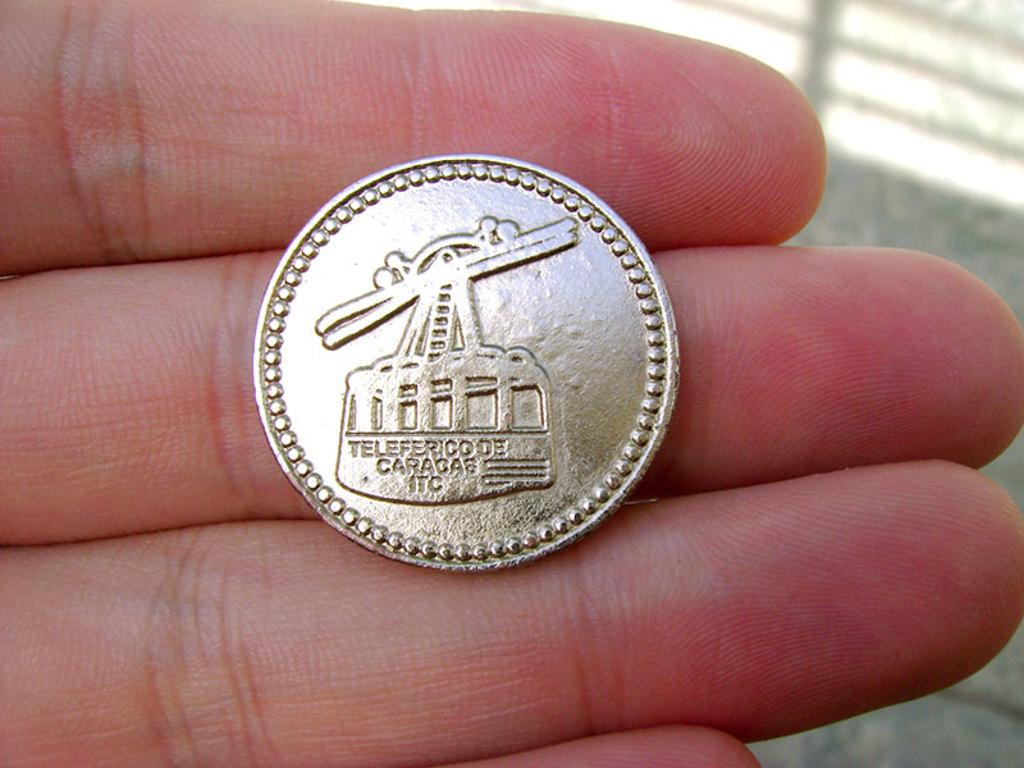What object is visible on a person's fingers in the image? There is a coin on a person's fingers in the image. Can you describe the object in more detail? The object is a coin, which is a small, flat, and round piece of metal used as currency. What type of can is visible in the image? There is no can present in the image; it only features a coin on a person's fingers. 